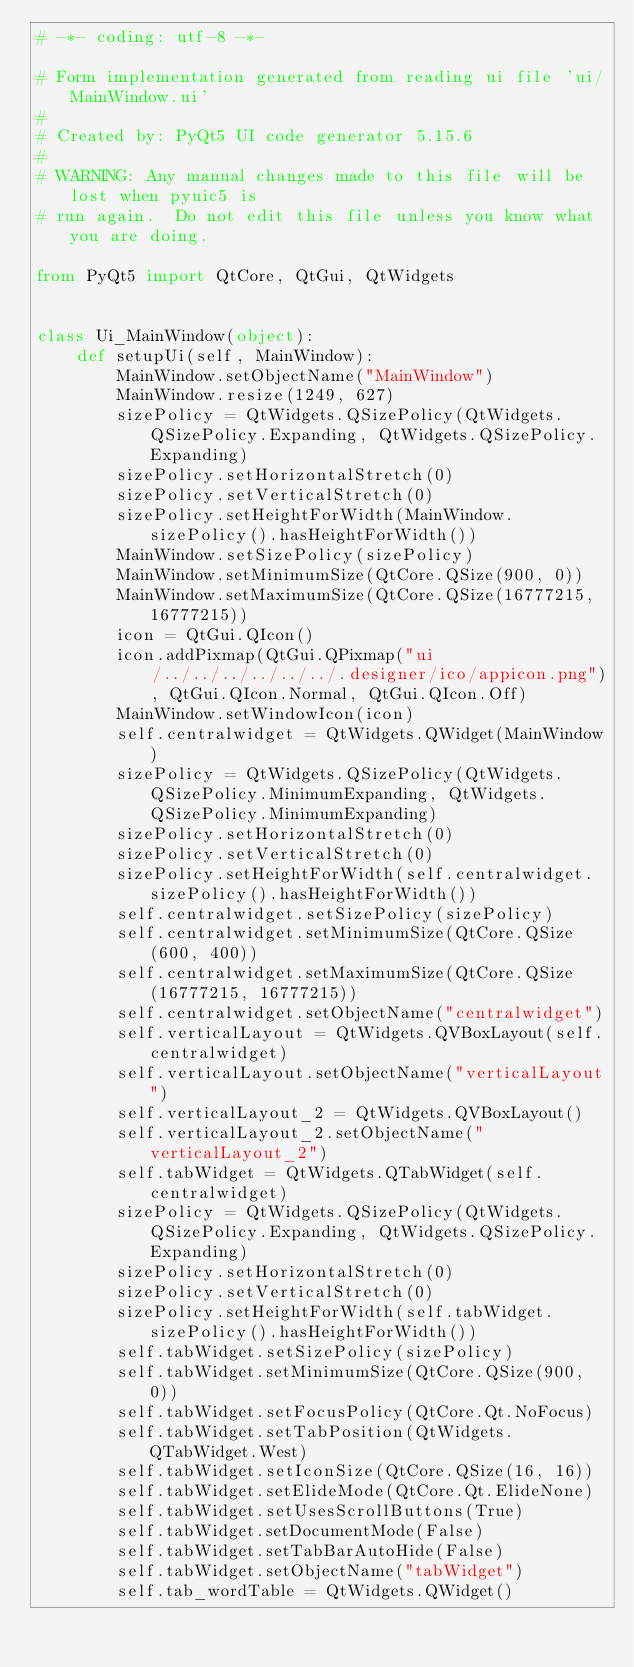Convert code to text. <code><loc_0><loc_0><loc_500><loc_500><_Python_># -*- coding: utf-8 -*-

# Form implementation generated from reading ui file 'ui/MainWindow.ui'
#
# Created by: PyQt5 UI code generator 5.15.6
#
# WARNING: Any manual changes made to this file will be lost when pyuic5 is
# run again.  Do not edit this file unless you know what you are doing.

from PyQt5 import QtCore, QtGui, QtWidgets


class Ui_MainWindow(object):
    def setupUi(self, MainWindow):
        MainWindow.setObjectName("MainWindow")
        MainWindow.resize(1249, 627)
        sizePolicy = QtWidgets.QSizePolicy(QtWidgets.QSizePolicy.Expanding, QtWidgets.QSizePolicy.Expanding)
        sizePolicy.setHorizontalStretch(0)
        sizePolicy.setVerticalStretch(0)
        sizePolicy.setHeightForWidth(MainWindow.sizePolicy().hasHeightForWidth())
        MainWindow.setSizePolicy(sizePolicy)
        MainWindow.setMinimumSize(QtCore.QSize(900, 0))
        MainWindow.setMaximumSize(QtCore.QSize(16777215, 16777215))
        icon = QtGui.QIcon()
        icon.addPixmap(QtGui.QPixmap("ui/../../../../../../.designer/ico/appicon.png"), QtGui.QIcon.Normal, QtGui.QIcon.Off)
        MainWindow.setWindowIcon(icon)
        self.centralwidget = QtWidgets.QWidget(MainWindow)
        sizePolicy = QtWidgets.QSizePolicy(QtWidgets.QSizePolicy.MinimumExpanding, QtWidgets.QSizePolicy.MinimumExpanding)
        sizePolicy.setHorizontalStretch(0)
        sizePolicy.setVerticalStretch(0)
        sizePolicy.setHeightForWidth(self.centralwidget.sizePolicy().hasHeightForWidth())
        self.centralwidget.setSizePolicy(sizePolicy)
        self.centralwidget.setMinimumSize(QtCore.QSize(600, 400))
        self.centralwidget.setMaximumSize(QtCore.QSize(16777215, 16777215))
        self.centralwidget.setObjectName("centralwidget")
        self.verticalLayout = QtWidgets.QVBoxLayout(self.centralwidget)
        self.verticalLayout.setObjectName("verticalLayout")
        self.verticalLayout_2 = QtWidgets.QVBoxLayout()
        self.verticalLayout_2.setObjectName("verticalLayout_2")
        self.tabWidget = QtWidgets.QTabWidget(self.centralwidget)
        sizePolicy = QtWidgets.QSizePolicy(QtWidgets.QSizePolicy.Expanding, QtWidgets.QSizePolicy.Expanding)
        sizePolicy.setHorizontalStretch(0)
        sizePolicy.setVerticalStretch(0)
        sizePolicy.setHeightForWidth(self.tabWidget.sizePolicy().hasHeightForWidth())
        self.tabWidget.setSizePolicy(sizePolicy)
        self.tabWidget.setMinimumSize(QtCore.QSize(900, 0))
        self.tabWidget.setFocusPolicy(QtCore.Qt.NoFocus)
        self.tabWidget.setTabPosition(QtWidgets.QTabWidget.West)
        self.tabWidget.setIconSize(QtCore.QSize(16, 16))
        self.tabWidget.setElideMode(QtCore.Qt.ElideNone)
        self.tabWidget.setUsesScrollButtons(True)
        self.tabWidget.setDocumentMode(False)
        self.tabWidget.setTabBarAutoHide(False)
        self.tabWidget.setObjectName("tabWidget")
        self.tab_wordTable = QtWidgets.QWidget()</code> 